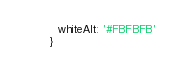Convert code to text. <code><loc_0><loc_0><loc_500><loc_500><_JavaScript_>  whiteAlt: '#FBFBFB'
}
</code> 